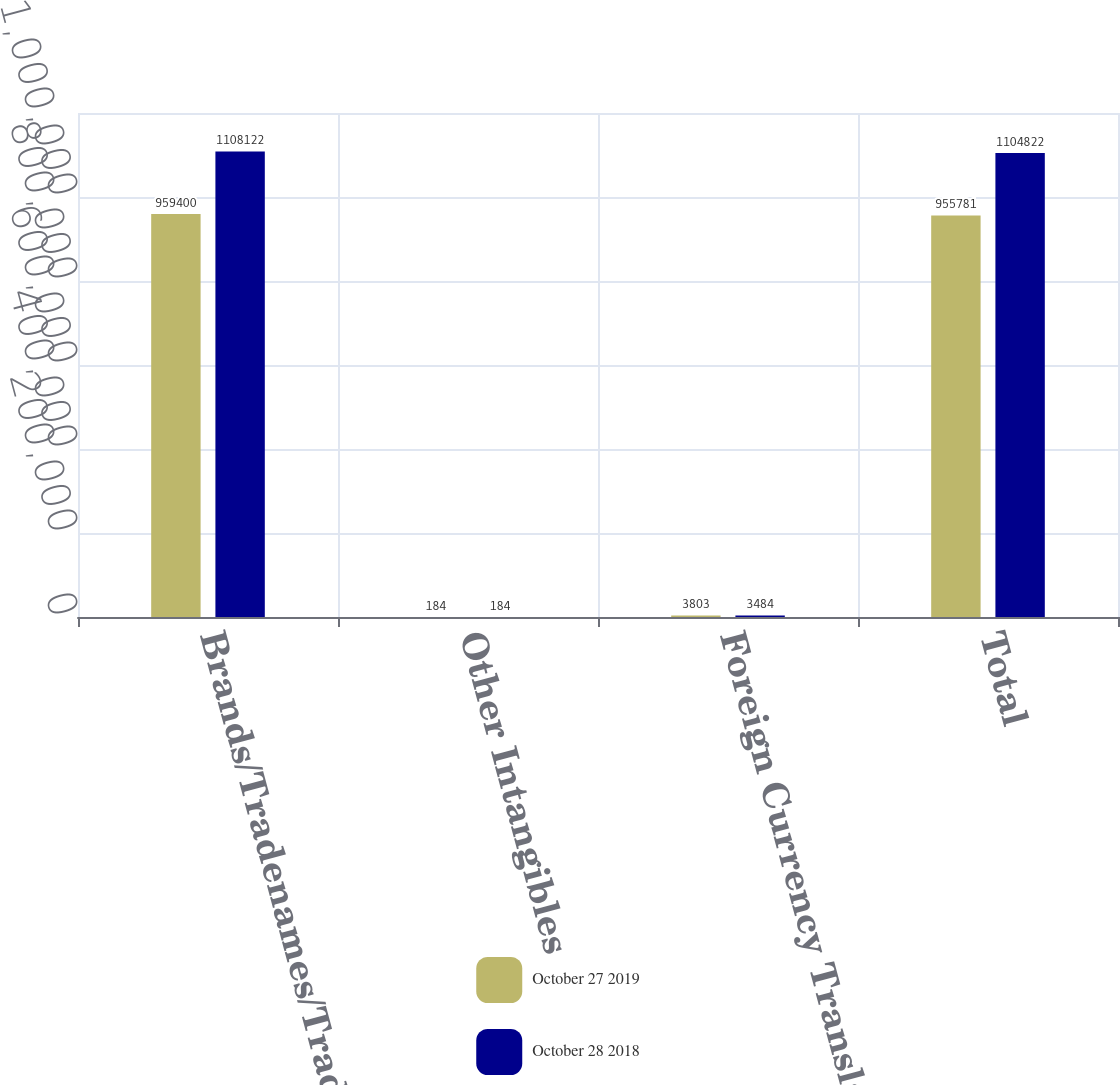Convert chart to OTSL. <chart><loc_0><loc_0><loc_500><loc_500><stacked_bar_chart><ecel><fcel>Brands/Tradenames/Trademarks<fcel>Other Intangibles<fcel>Foreign Currency Translation<fcel>Total<nl><fcel>October 27 2019<fcel>959400<fcel>184<fcel>3803<fcel>955781<nl><fcel>October 28 2018<fcel>1.10812e+06<fcel>184<fcel>3484<fcel>1.10482e+06<nl></chart> 